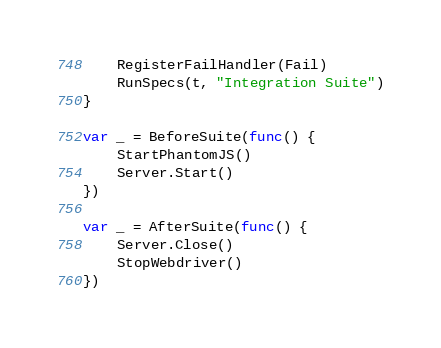Convert code to text. <code><loc_0><loc_0><loc_500><loc_500><_Go_>	RegisterFailHandler(Fail)
	RunSpecs(t, "Integration Suite")
}

var _ = BeforeSuite(func() {
	StartPhantomJS()
	Server.Start()
})

var _ = AfterSuite(func() {
	Server.Close()
	StopWebdriver()
})
</code> 